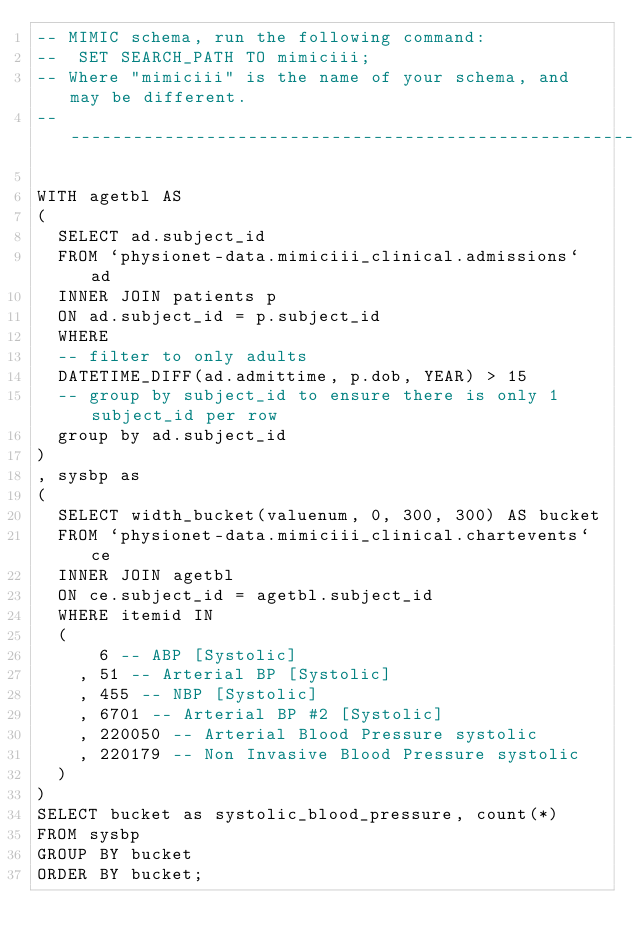Convert code to text. <code><loc_0><loc_0><loc_500><loc_500><_SQL_>-- MIMIC schema, run the following command:
--  SET SEARCH_PATH TO mimiciii;
-- Where "mimiciii" is the name of your schema, and may be different.
-- --------------------------------------------------------

WITH agetbl AS
(
  SELECT ad.subject_id
  FROM `physionet-data.mimiciii_clinical.admissions` ad
  INNER JOIN patients p
  ON ad.subject_id = p.subject_id
  WHERE
  -- filter to only adults
  DATETIME_DIFF(ad.admittime, p.dob, YEAR) > 15
  -- group by subject_id to ensure there is only 1 subject_id per row
  group by ad.subject_id
)
, sysbp as
(
  SELECT width_bucket(valuenum, 0, 300, 300) AS bucket
  FROM `physionet-data.mimiciii_clinical.chartevents` ce
  INNER JOIN agetbl
  ON ce.subject_id = agetbl.subject_id
  WHERE itemid IN
  (
      6 -- ABP [Systolic]
    , 51 -- Arterial BP [Systolic]
    , 455 -- NBP [Systolic]
    , 6701 -- Arterial BP #2 [Systolic]
    , 220050 -- Arterial Blood Pressure systolic
    , 220179 -- Non Invasive Blood Pressure systolic
  )
)
SELECT bucket as systolic_blood_pressure, count(*)
FROM sysbp
GROUP BY bucket
ORDER BY bucket;
</code> 